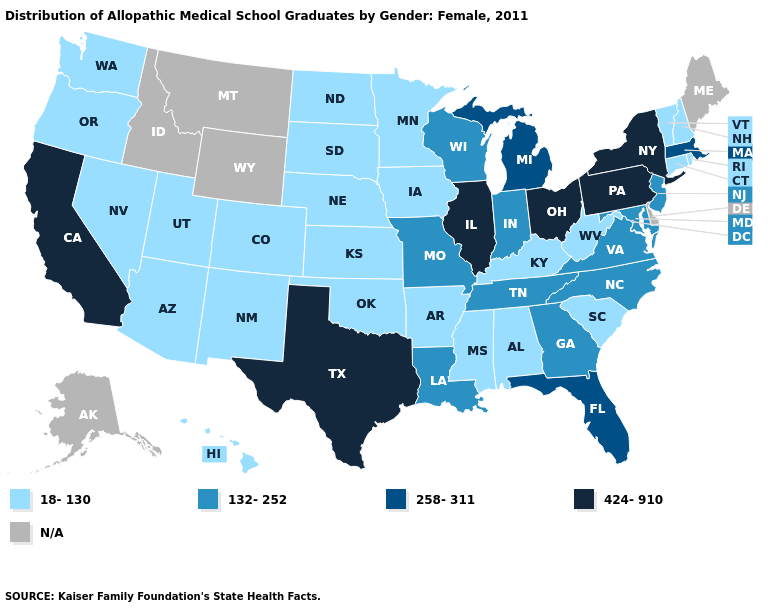Name the states that have a value in the range 18-130?
Answer briefly. Alabama, Arizona, Arkansas, Colorado, Connecticut, Hawaii, Iowa, Kansas, Kentucky, Minnesota, Mississippi, Nebraska, Nevada, New Hampshire, New Mexico, North Dakota, Oklahoma, Oregon, Rhode Island, South Carolina, South Dakota, Utah, Vermont, Washington, West Virginia. How many symbols are there in the legend?
Quick response, please. 5. What is the lowest value in the West?
Keep it brief. 18-130. Which states have the highest value in the USA?
Keep it brief. California, Illinois, New York, Ohio, Pennsylvania, Texas. What is the lowest value in the USA?
Concise answer only. 18-130. What is the lowest value in the USA?
Concise answer only. 18-130. Which states have the lowest value in the MidWest?
Quick response, please. Iowa, Kansas, Minnesota, Nebraska, North Dakota, South Dakota. Does Texas have the highest value in the USA?
Keep it brief. Yes. What is the highest value in the South ?
Write a very short answer. 424-910. Name the states that have a value in the range 258-311?
Concise answer only. Florida, Massachusetts, Michigan. What is the value of Arkansas?
Short answer required. 18-130. What is the value of Massachusetts?
Be succinct. 258-311. Which states have the highest value in the USA?
Give a very brief answer. California, Illinois, New York, Ohio, Pennsylvania, Texas. Name the states that have a value in the range 258-311?
Give a very brief answer. Florida, Massachusetts, Michigan. 